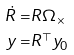<formula> <loc_0><loc_0><loc_500><loc_500>\dot { R } = & R \Omega _ { \times } \\ y = & R ^ { \top } y _ { 0 }</formula> 